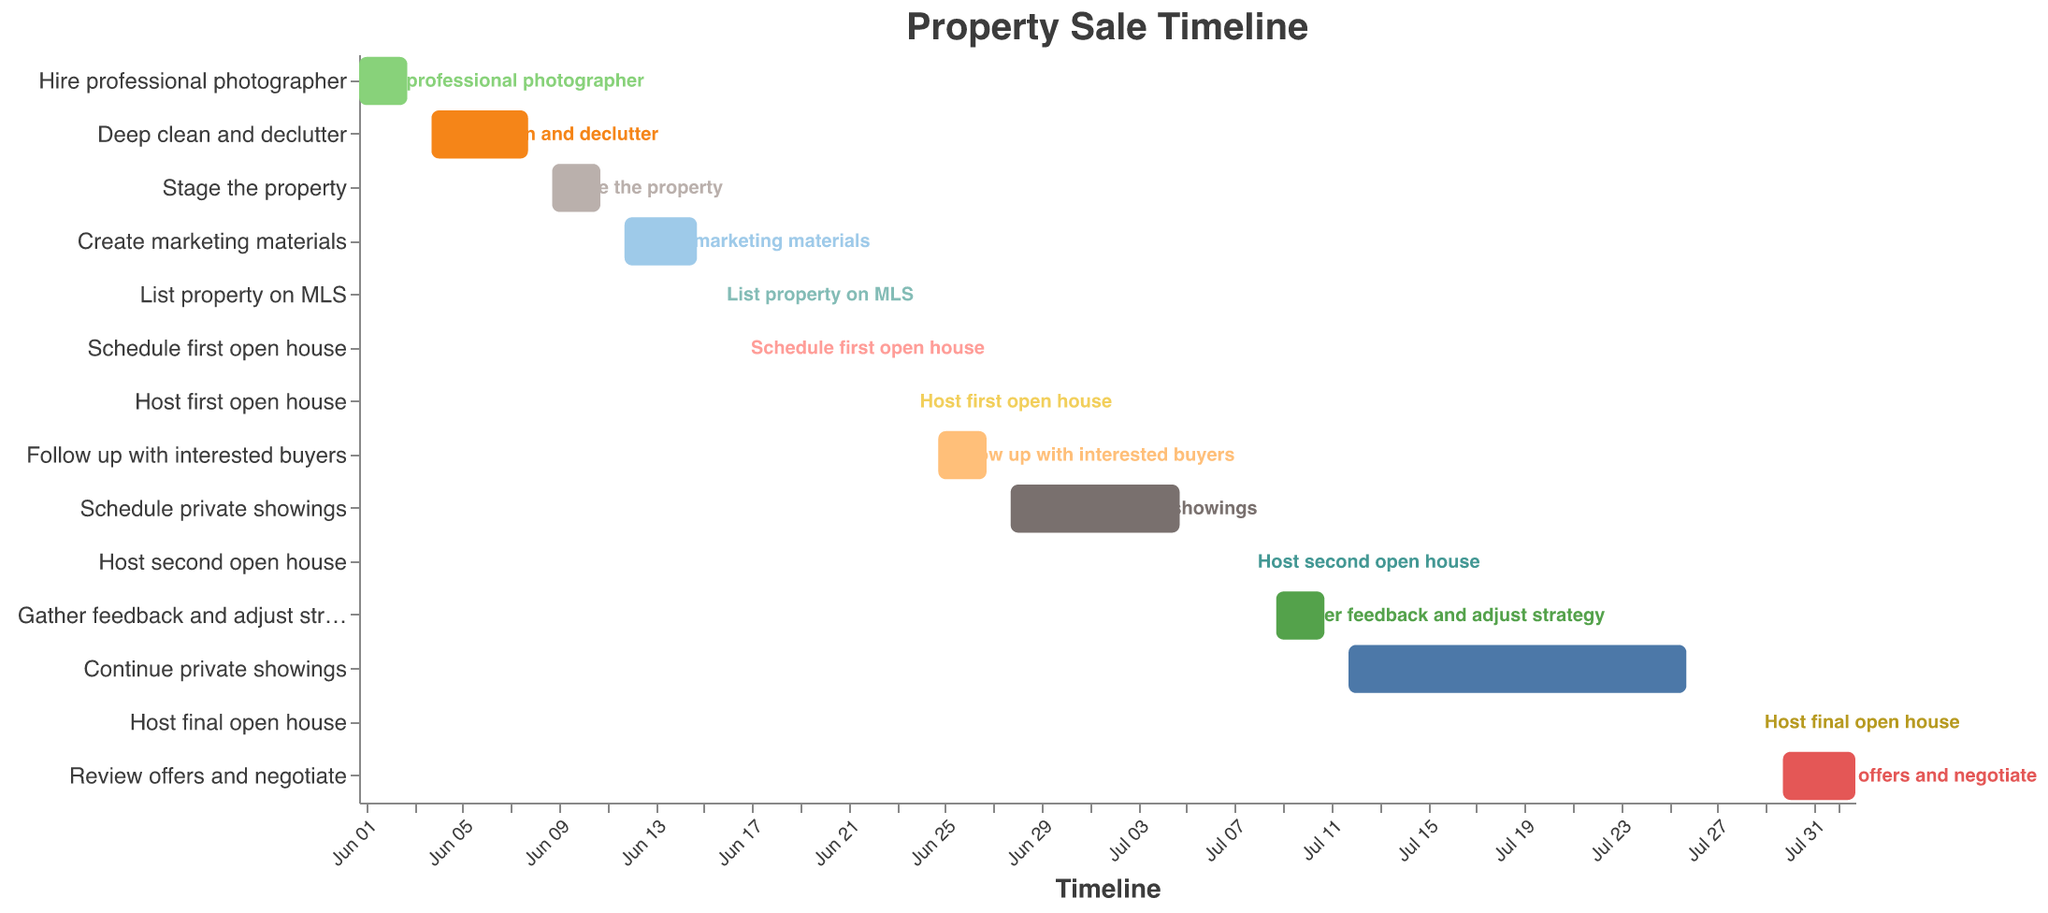What is the title of the Gantt Chart? The title is typically placed at the top of the Gantt Chart in larger font size and distinct color to highlight its significance. The title here is clearly labeled.
Answer: Property Sale Timeline How many tasks are scheduled from June 1st to June 15th? By examining the timeline from June 1st to June 15th, we identify the tasks listed during this period. The tasks are: Hire professional photographer, Deep clean and declutter, Stage the property, and Create marketing materials. This sums up to 4 tasks.
Answer: 4 tasks When does the task "Schedule private showings" start and end? Look for the task named "Schedule private showings" on the y-axis and trace its corresponding segment along the x-axis. It starts on June 28th and ends on July 5th.
Answer: June 28th to July 5th Which task has the longest duration? To find the task with the longest duration, compare the length of all bars. "Continue private showings" spans from July 12th to July 26th, which is a total of 15 days.
Answer: Continue private showings How many days in total are spent on open house events? Add the durations of all tasks related to open house events, specifically "Host first open house" (1 day), "Host second open house" (1 day), and "Host final open house" (1 day). Thus, the total is 1 + 1 + 1 = 3 days.
Answer: 3 days Can you list the tasks that occur after "Host first open house" and provide their start dates? Identify "Host first open house" on the chart, which is on June 24th. The tasks after this are: Follow up with interested buyers (June 25th), Schedule private showings (June 28th), Host second open house (July 8th), Gather feedback and adjust strategy (July 9th), Continue private showings (July 12th), Host final open house (July 29th), and Review offers and negotiate (July 30th).
Answer: Follow up with interested buyers (June 25th), Schedule private showings (June 28th), Host second open house (July 8th), Gather feedback and adjust strategy (July 9th), Continue private showings (July 12th), Host final open house (July 29th), Review offers and negotiate (July 30th) How many days of downtime (no tasks scheduled) are there between the last task in June and the first task in July? Observe that the last task in June is "Schedule private showings," which ends on July 5th. The first task in July, "Host second open house," starts on July 8th. Hence, there are no tasks from July 6th to July 7th, making it a 2-day downtime.
Answer: 2 days Compare the duration of "Create marketing materials" and "Review offers and negotiate." Which task takes longer, and by how many days? The duration of "Create marketing materials" is 4 days, and "Review offers and negotiate" is 4 days. Since both have the same duration, neither task takes longer.
Answer: Neither, both are 4 days What is the primary color scheme used in the Gantt Chart? The Gantt Chart employs a color scheme which is predefined for better visual segmentation. Here, the color scheme used is "tableau20," which includes a variety of vibrant and distinct colors.
Answer: Tableau 20 